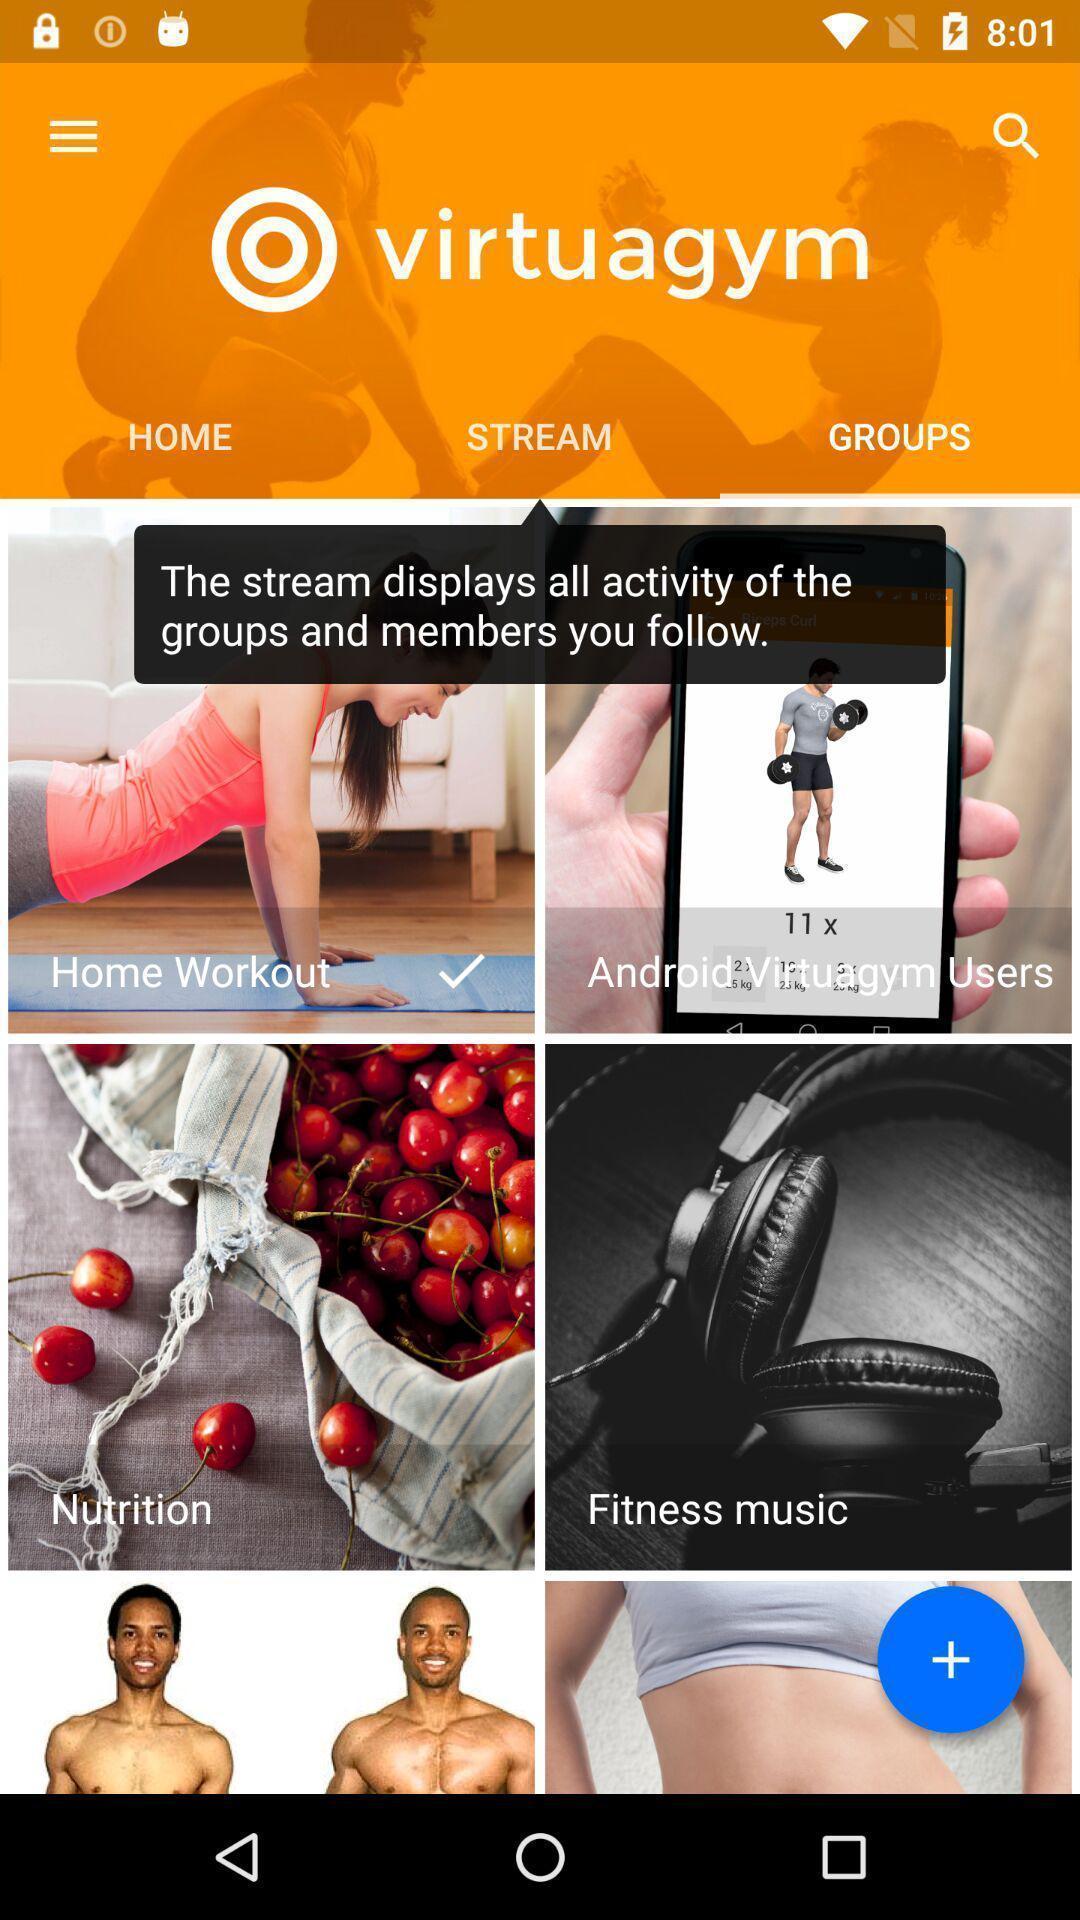Describe the key features of this screenshot. Showing groups page of a fitness app. 